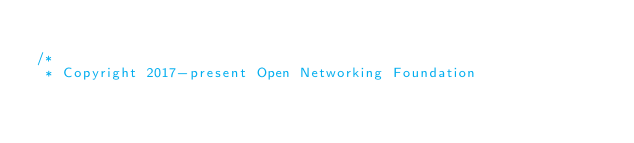Convert code to text. <code><loc_0><loc_0><loc_500><loc_500><_JavaScript_>
/*
 * Copyright 2017-present Open Networking Foundation
</code> 